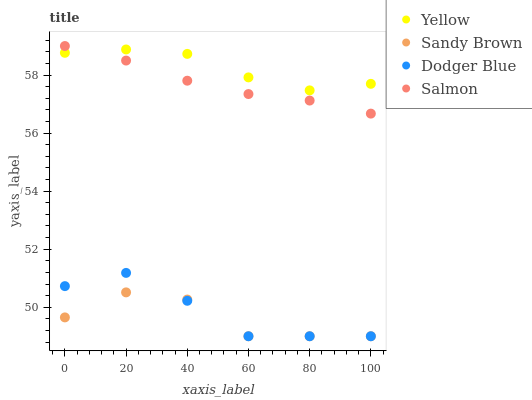Does Sandy Brown have the minimum area under the curve?
Answer yes or no. Yes. Does Yellow have the maximum area under the curve?
Answer yes or no. Yes. Does Yellow have the minimum area under the curve?
Answer yes or no. No. Does Sandy Brown have the maximum area under the curve?
Answer yes or no. No. Is Salmon the smoothest?
Answer yes or no. Yes. Is Sandy Brown the roughest?
Answer yes or no. Yes. Is Yellow the smoothest?
Answer yes or no. No. Is Yellow the roughest?
Answer yes or no. No. Does Dodger Blue have the lowest value?
Answer yes or no. Yes. Does Yellow have the lowest value?
Answer yes or no. No. Does Salmon have the highest value?
Answer yes or no. Yes. Does Yellow have the highest value?
Answer yes or no. No. Is Dodger Blue less than Salmon?
Answer yes or no. Yes. Is Salmon greater than Sandy Brown?
Answer yes or no. Yes. Does Sandy Brown intersect Dodger Blue?
Answer yes or no. Yes. Is Sandy Brown less than Dodger Blue?
Answer yes or no. No. Is Sandy Brown greater than Dodger Blue?
Answer yes or no. No. Does Dodger Blue intersect Salmon?
Answer yes or no. No. 